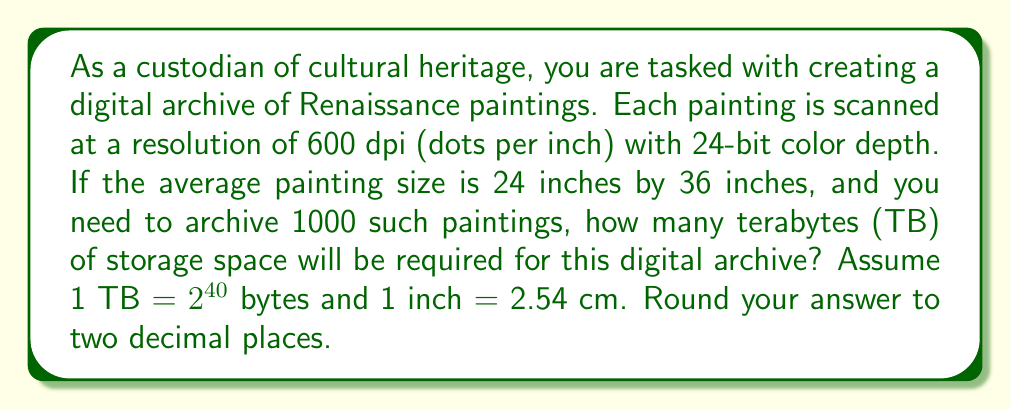Provide a solution to this math problem. Let's approach this step-by-step:

1) First, let's calculate the number of pixels for each painting:
   - Width in pixels: 24 inches * 600 dpi = 14,400 pixels
   - Height in pixels: 36 inches * 600 dpi = 21,600 pixels
   - Total pixels per painting: 14,400 * 21,600 = 311,040,000 pixels

2) Each pixel requires 24 bits (3 bytes) of storage:
   - Storage per painting: 311,040,000 * 3 = 933,120,000 bytes

3) For 1000 paintings:
   - Total storage: 933,120,000 * 1000 = 933,120,000,000 bytes

4) Convert bytes to terabytes:
   $$\text{TB} = \frac{933,120,000,000}{2^{40}} \approx 0.8480072021484375\text{ TB}$$

5) Rounding to two decimal places:
   0.85 TB

This amount of storage might seem surprisingly small for such high-resolution scans, but it demonstrates the efficiency of digital storage compared to physical artifacts, a concept that might be particularly intriguing to a luddite art historian.
Answer: 0.85 TB 